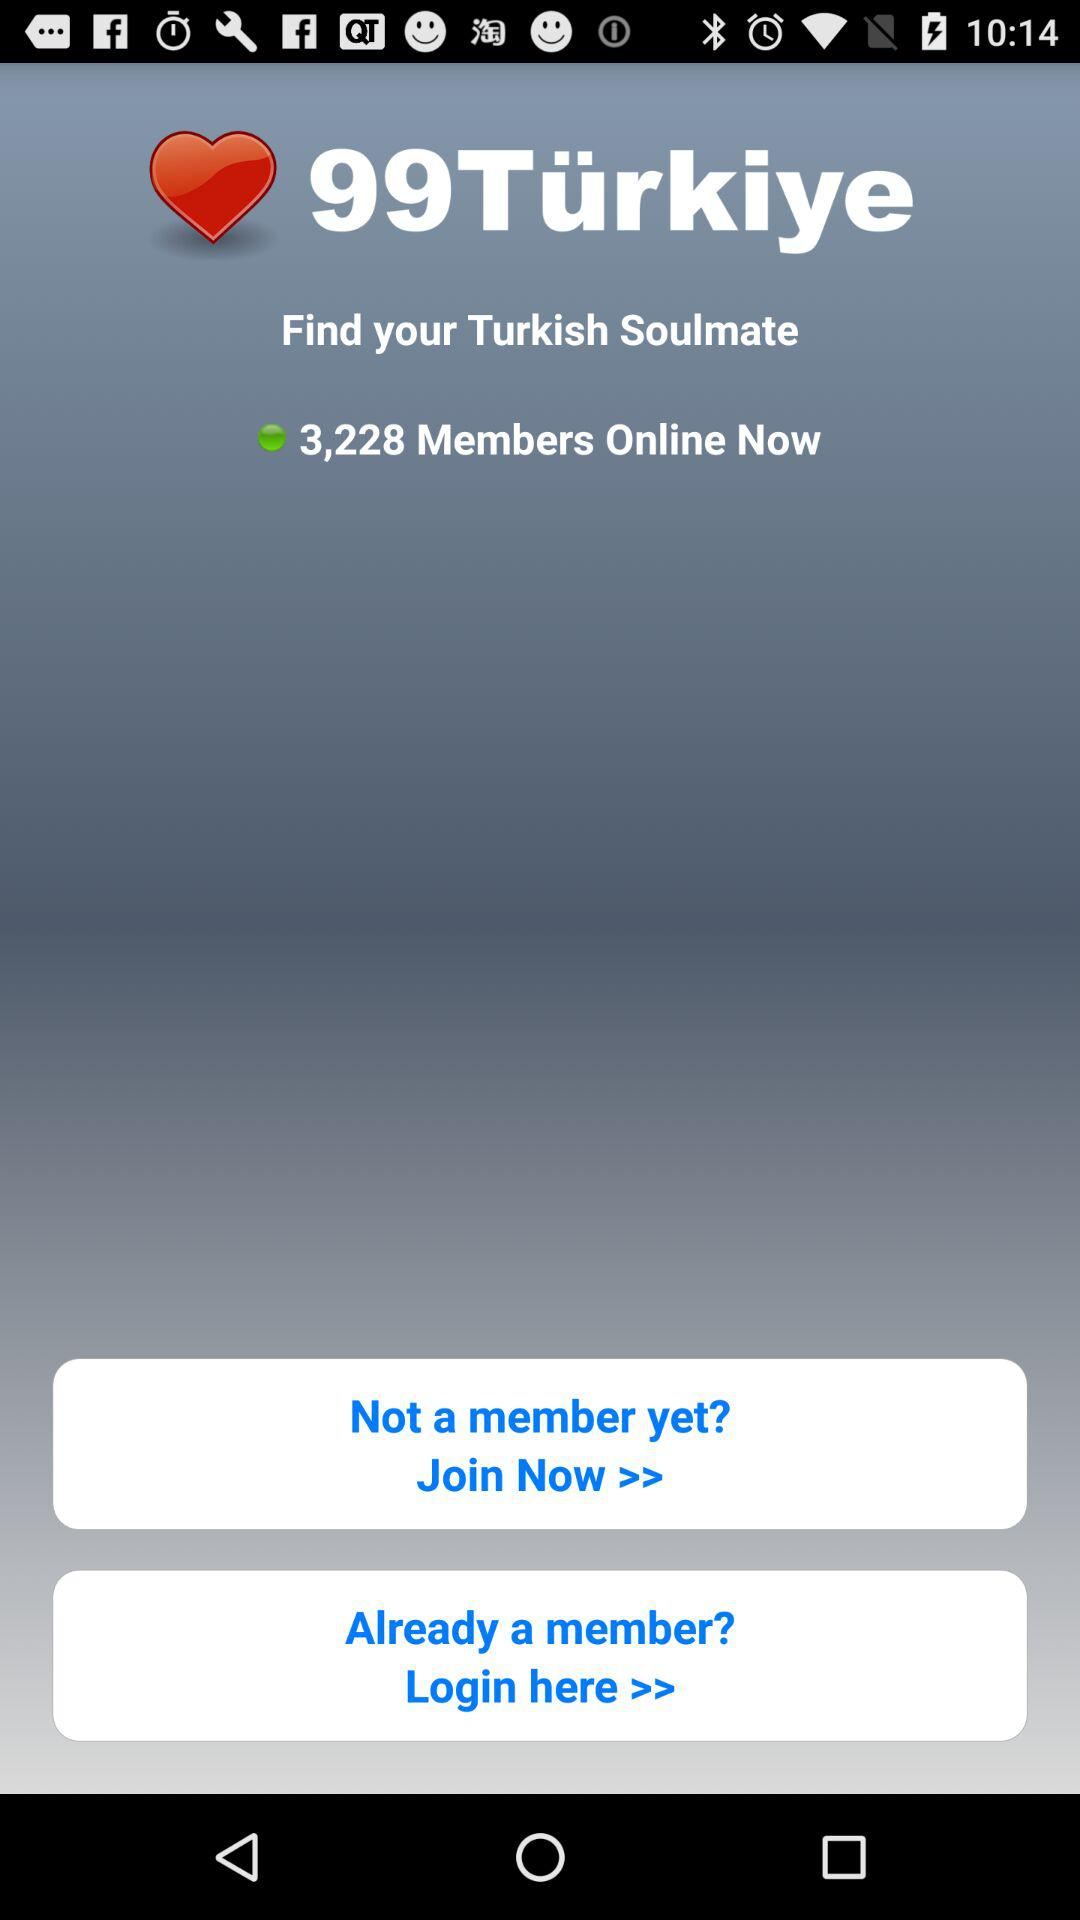What is the application name? The application name is "99Türkiye". 